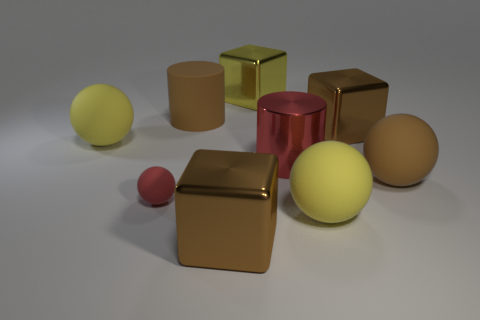Subtract all green balls. Subtract all yellow cylinders. How many balls are left? 4 Add 1 blue objects. How many objects exist? 10 Subtract all cylinders. How many objects are left? 7 Add 5 red matte spheres. How many red matte spheres are left? 6 Add 8 tiny green matte balls. How many tiny green matte balls exist? 8 Subtract 0 cyan spheres. How many objects are left? 9 Subtract all brown blocks. Subtract all large yellow metallic blocks. How many objects are left? 6 